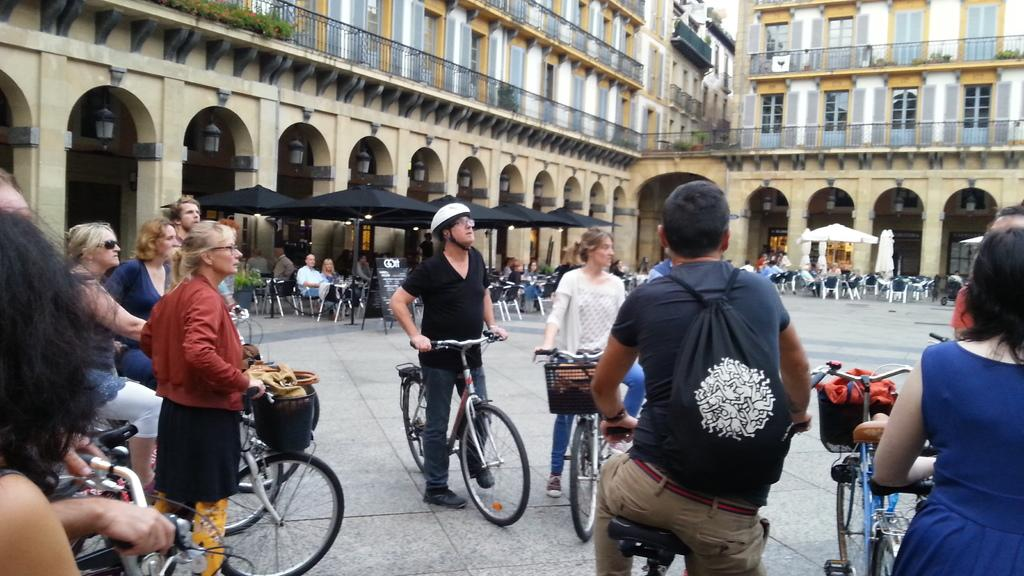What are the people in the image doing? The people in the image are standing and holding bicycles. What objects can be seen in the background of the image? There are chairs and walls in the background of the image. What color are the walls in the image? The walls in the image are yellow. What type of chalk is being used by the doctor in the image? There is no doctor or chalk present in the image. How many bulbs are visible in the image? There are no bulbs visible in the image. 